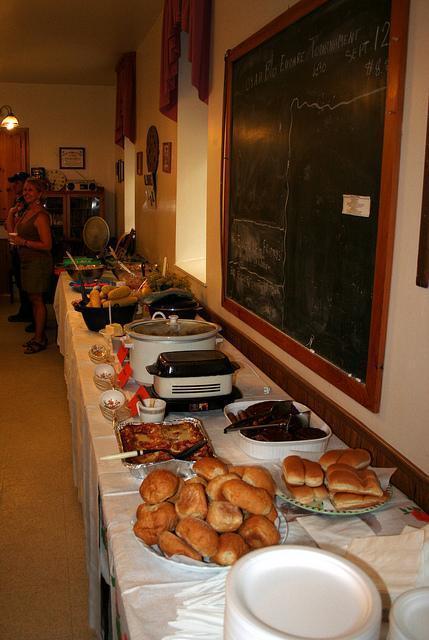How many lights do you see on the ceiling?
Give a very brief answer. 1. How many bowls are in the picture?
Give a very brief answer. 2. How many dogs are wearing a leash?
Give a very brief answer. 0. 